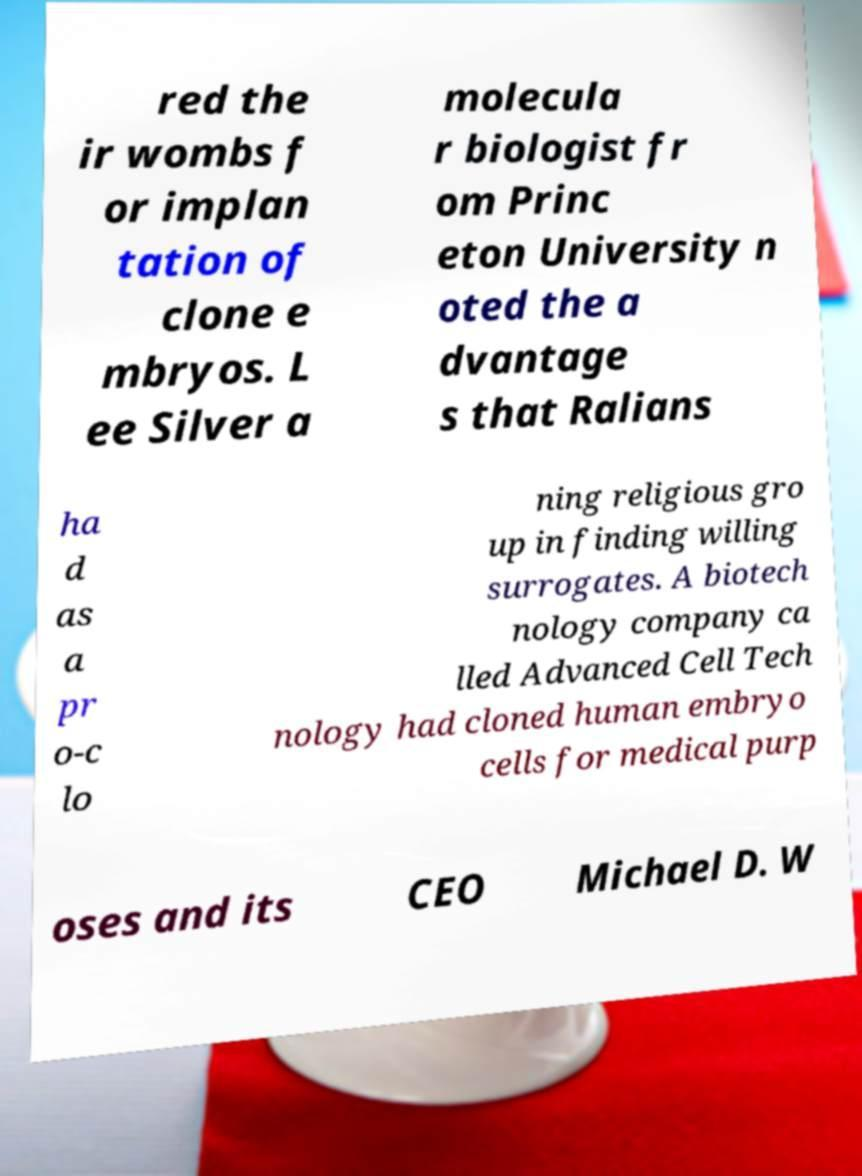What messages or text are displayed in this image? I need them in a readable, typed format. red the ir wombs f or implan tation of clone e mbryos. L ee Silver a molecula r biologist fr om Princ eton University n oted the a dvantage s that Ralians ha d as a pr o-c lo ning religious gro up in finding willing surrogates. A biotech nology company ca lled Advanced Cell Tech nology had cloned human embryo cells for medical purp oses and its CEO Michael D. W 